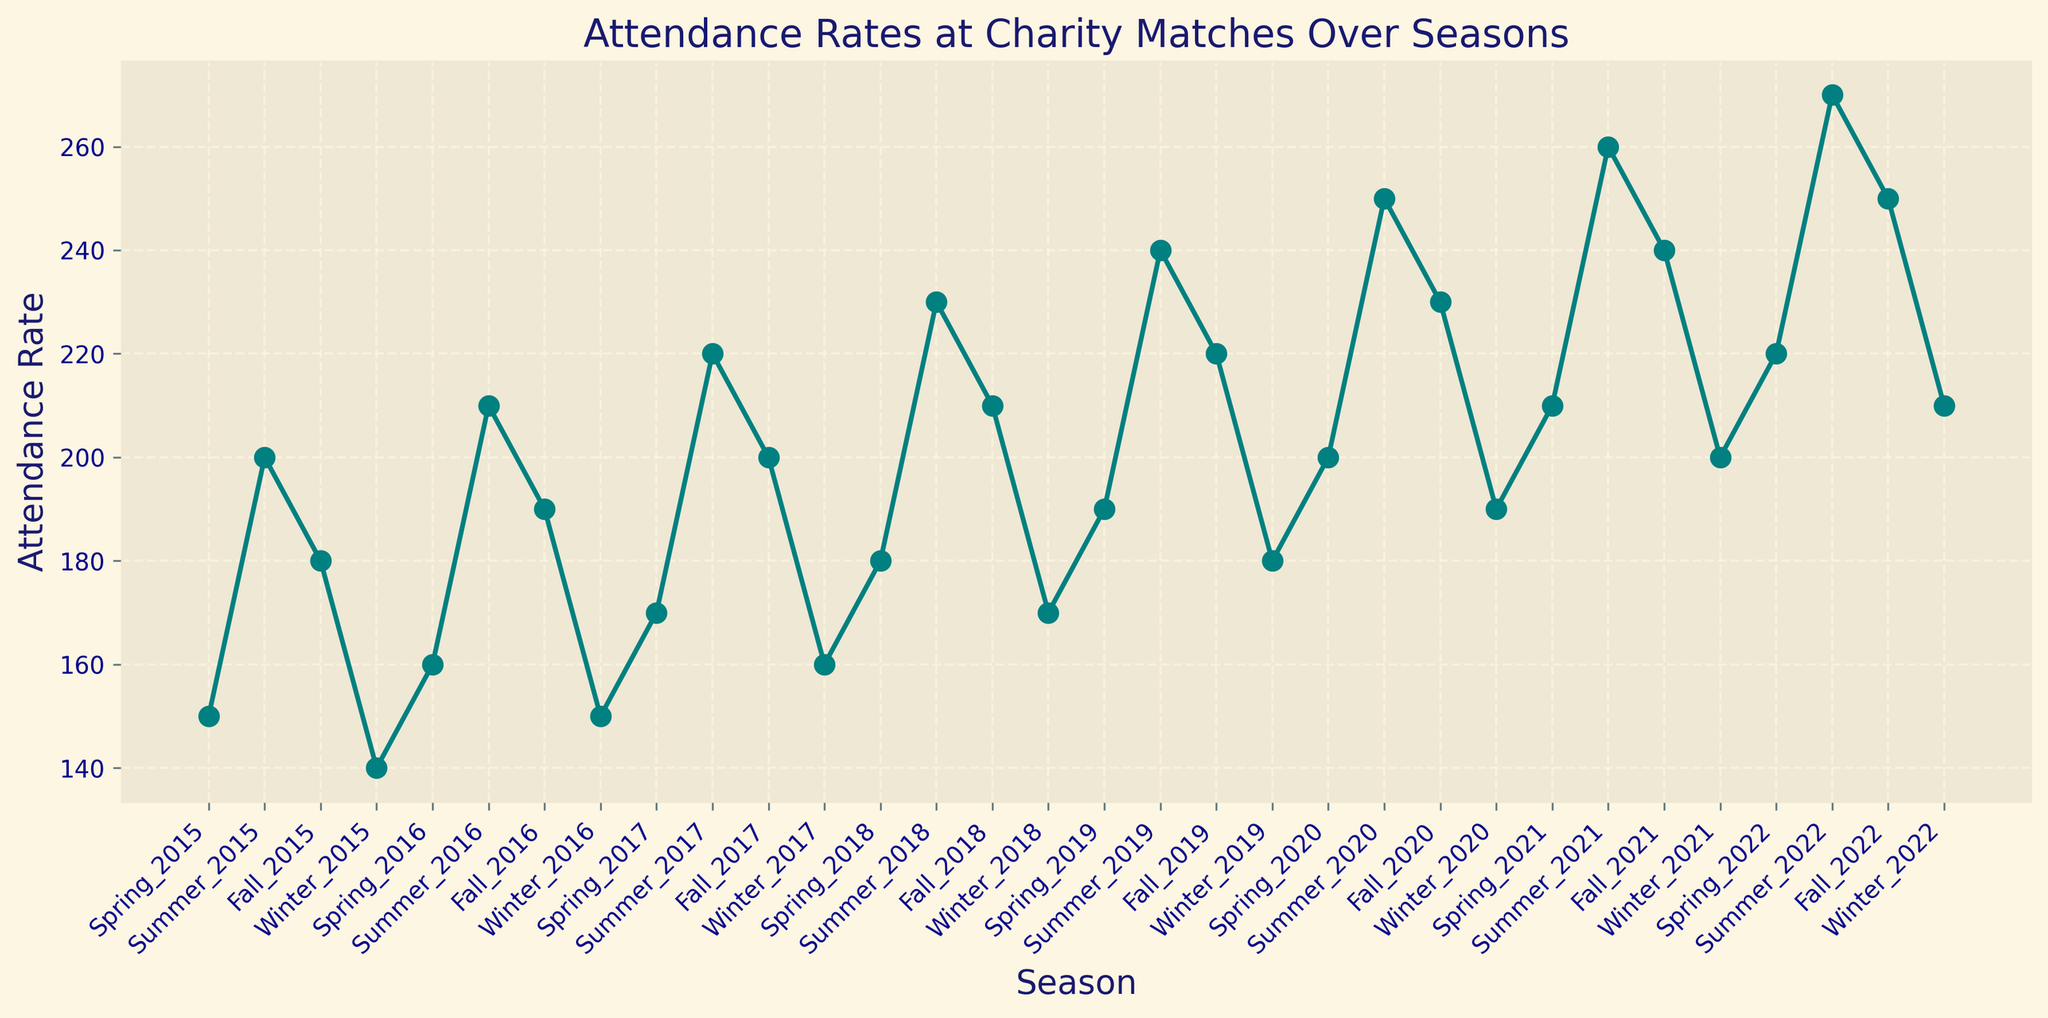What's the general trend of attendance rates from Spring_2015 to Winter_2022? By examining the overall pattern of the line plot from Spring_2015 to Winter_2022, it can be observed that the attendance rates generally increase over the seasons, despite some fluctuations during the winter seasons.
Answer: Generally increasing Which season had the highest attendance rate? From the plot, the point at Summer_2022 is the highest, indicating the maximum attendance rate.
Answer: Summer_2022 What is the average attendance rate for all summer seasons? Identify the attendance rates for Summer_2015, Summer_2016, Summer_2017, Summer_2018, Summer_2019, Summer_2020, Summer_2021, and Summer_2022. Add them up and divide by 8: (200 + 210 + 220 + 230 + 240 + 250 + 260 + 270)/8 = 235
Answer: 235 Which season saw the steepest increase in attendance rate? The largest difference between consecutive seasons suggests the steepest increase. From Summer_2021 (260) to Summer_2022 (270), the increase is 10, which is the most significant in the chart.
Answer: Summer_2021 to Summer_2022 How much did the attendance rate change from Winter_2015 to Winter_2022? Attendance rate in Winter_2015 was 140 and in Winter_2022 was 210. The difference is 210 - 140 = 70.
Answer: 70 Which year had the highest average attendance rate across its seasons? Calculate the average attendance rate for each year by summing the rates of all four seasons and dividing by 4. For example, 2015 has (150+200+180+140)/4 = 167.5, and so on. 2022 has the highest average with (220+270+250+210)/4 = 237.5.
Answer: 2022 What visual feature helps distinguish the different seasons? The line plot uses distinct markers (circles) and colors to differentiate between the seasons. Each season's data point is connected with a teal-colored line to show trends.
Answer: Markers and color Which season in any year always shows a decline compared to the previous season except for one instance, and which instance is that? Winter seasons generally show a decline from the previous Fall season except in Winter_2016, where there is an increase from Fall_2016 (150 compared to 140).
Answer: Winter, Winter_2016 What do you notice visually about the attendance rate trend in the month immediately following the summer seasons? There is a consistent decline in the attendance rate after the peak during summer seasons, as indicated by a dip in the points and line downward.
Answer: Consistent decline 